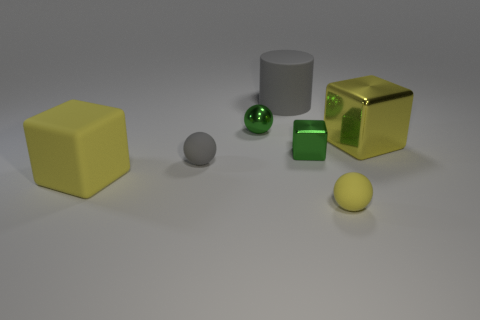Add 1 big yellow metal objects. How many objects exist? 8 Subtract all balls. How many objects are left? 4 Subtract 0 purple balls. How many objects are left? 7 Subtract all small gray rubber things. Subtract all small cubes. How many objects are left? 5 Add 2 yellow spheres. How many yellow spheres are left? 3 Add 7 large things. How many large things exist? 10 